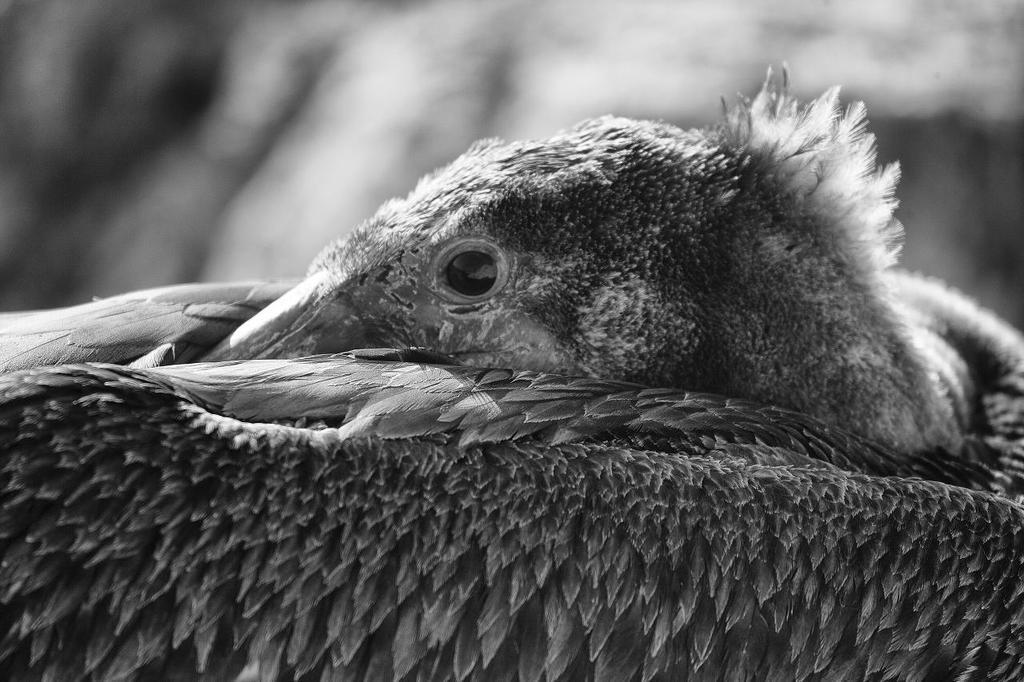Can you describe this image briefly? In the foreground of this black and white image, there is a bird and it is covering it´s face with the wings and the background image is blurred. 